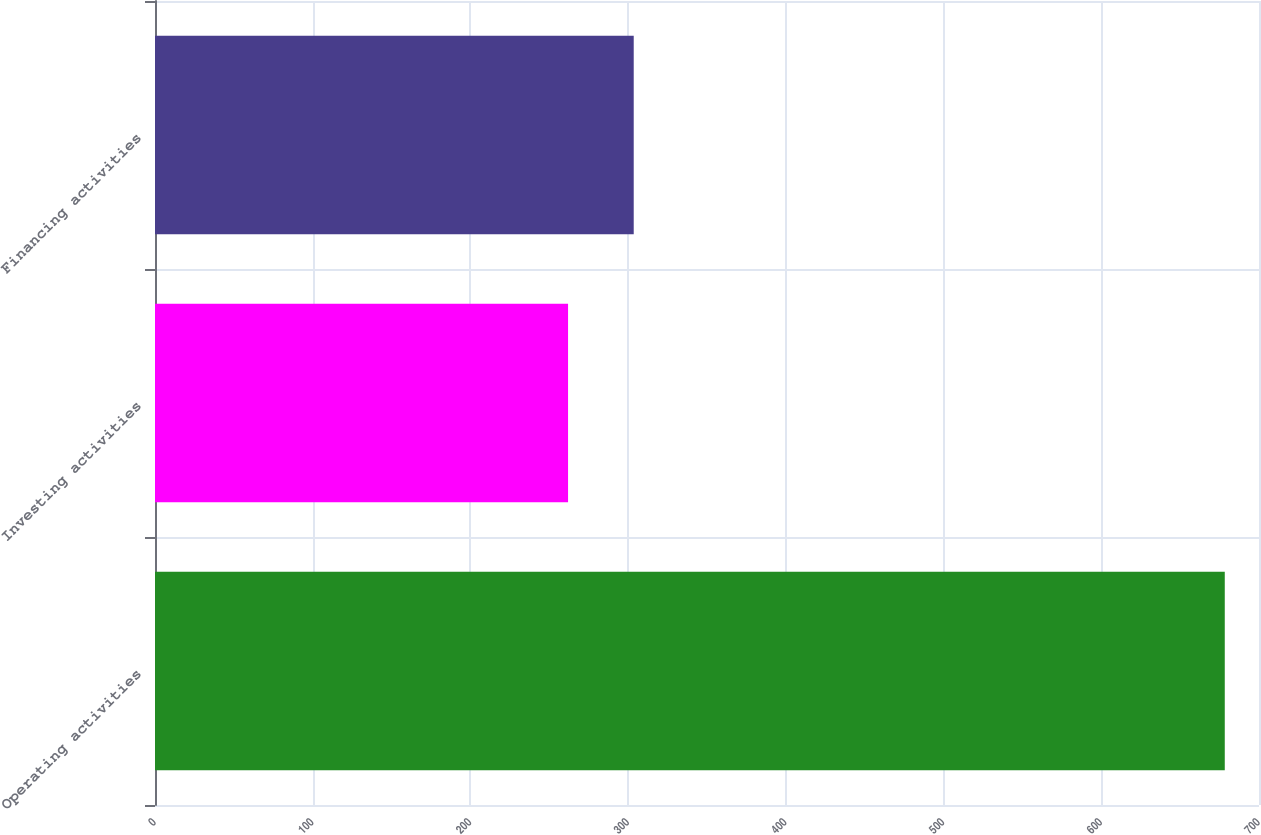<chart> <loc_0><loc_0><loc_500><loc_500><bar_chart><fcel>Operating activities<fcel>Investing activities<fcel>Financing activities<nl><fcel>678.3<fcel>261.9<fcel>303.54<nl></chart> 